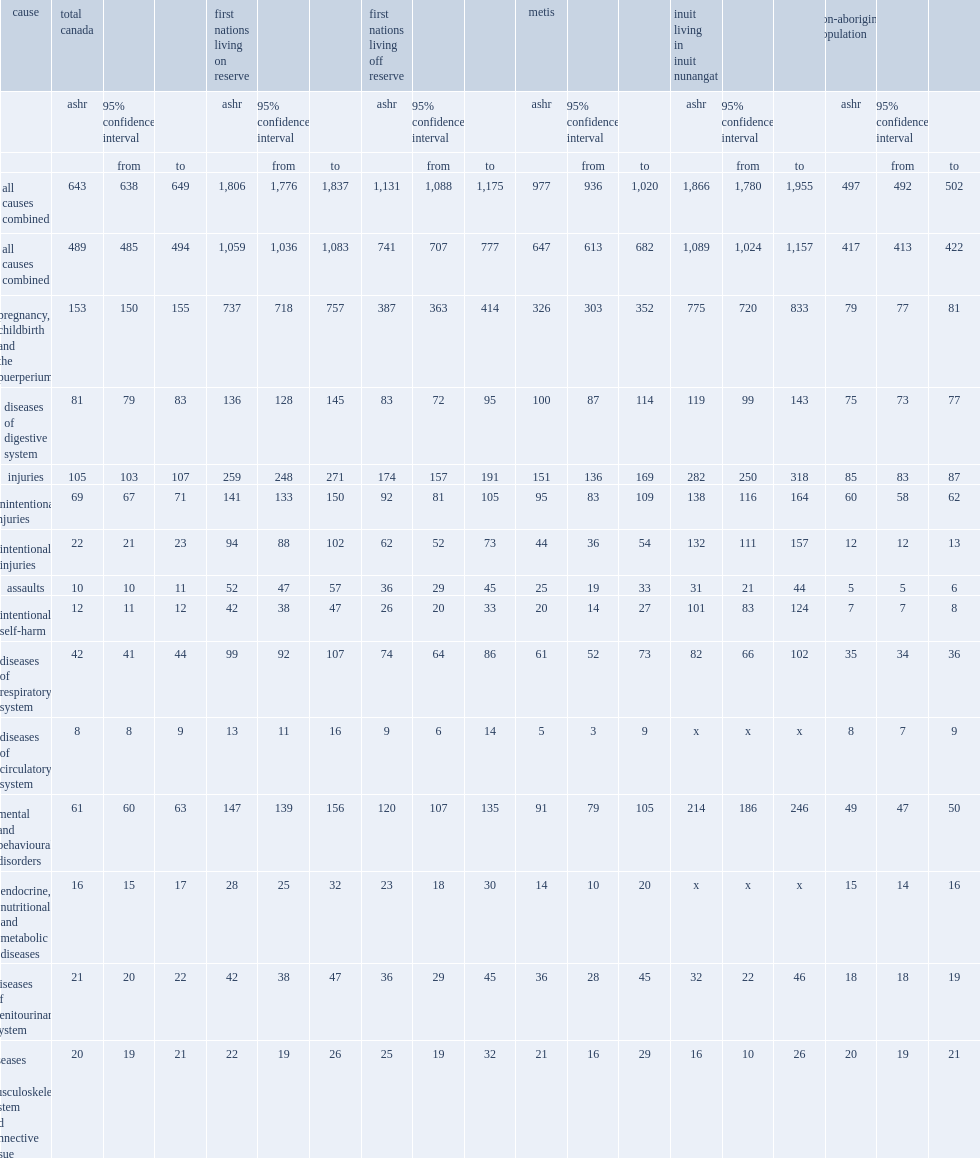Among 10- to 19-year-olds, which group had the highest overall hospitalization rate (including births)? Inuit living in inuit nunangat. Among 10- to 19-year-olds, how many times the overall hospitalization rate for inuit in inuit nunangat was that for non-aboriginal youth ? 3.754527. Among 10- to 19-year-olds,how many times the overall hospitalization rate for first nations youth living on reserve was that for non-aboriginal youth? 3.633803. Among 10- to 19-year-olds,how many times the overall hospitalization rate for first nations youth living off reserve was that for non-aboriginal youth? 2.275654. Among 10- to 19-year-olds,how many times the overall hospitalization rate for metis was that for non-aboriginal youth? 1.965795. When hospitalizations related to births were excluded, how many times the overall hospitalization rates at ages 10 to 19 for inuit was that for non-aboriginal youth? 2.611511. When hospitalizations related to births were excluded, how many times the overall hospitalization rates at ages 10 to 19 for first nations living on reserve was that for non-aboriginal youth? 2.539568. When hospitalizations related to births were excluded, how many times the overall hospitalization rates at ages 10 to 19 for first nations living off reserve was that for non-aboriginal youth? 1.776978. When hospitalizations related to births were excluded, how many times the overall hospitalization rates at ages 10 to 19 for metis was that for non-aboriginal youth? 1.551559. 